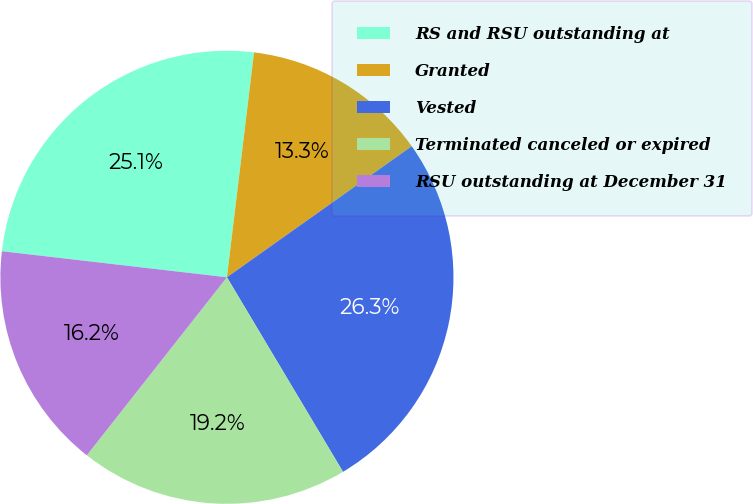Convert chart. <chart><loc_0><loc_0><loc_500><loc_500><pie_chart><fcel>RS and RSU outstanding at<fcel>Granted<fcel>Vested<fcel>Terminated canceled or expired<fcel>RSU outstanding at December 31<nl><fcel>25.07%<fcel>13.27%<fcel>26.25%<fcel>19.17%<fcel>16.22%<nl></chart> 